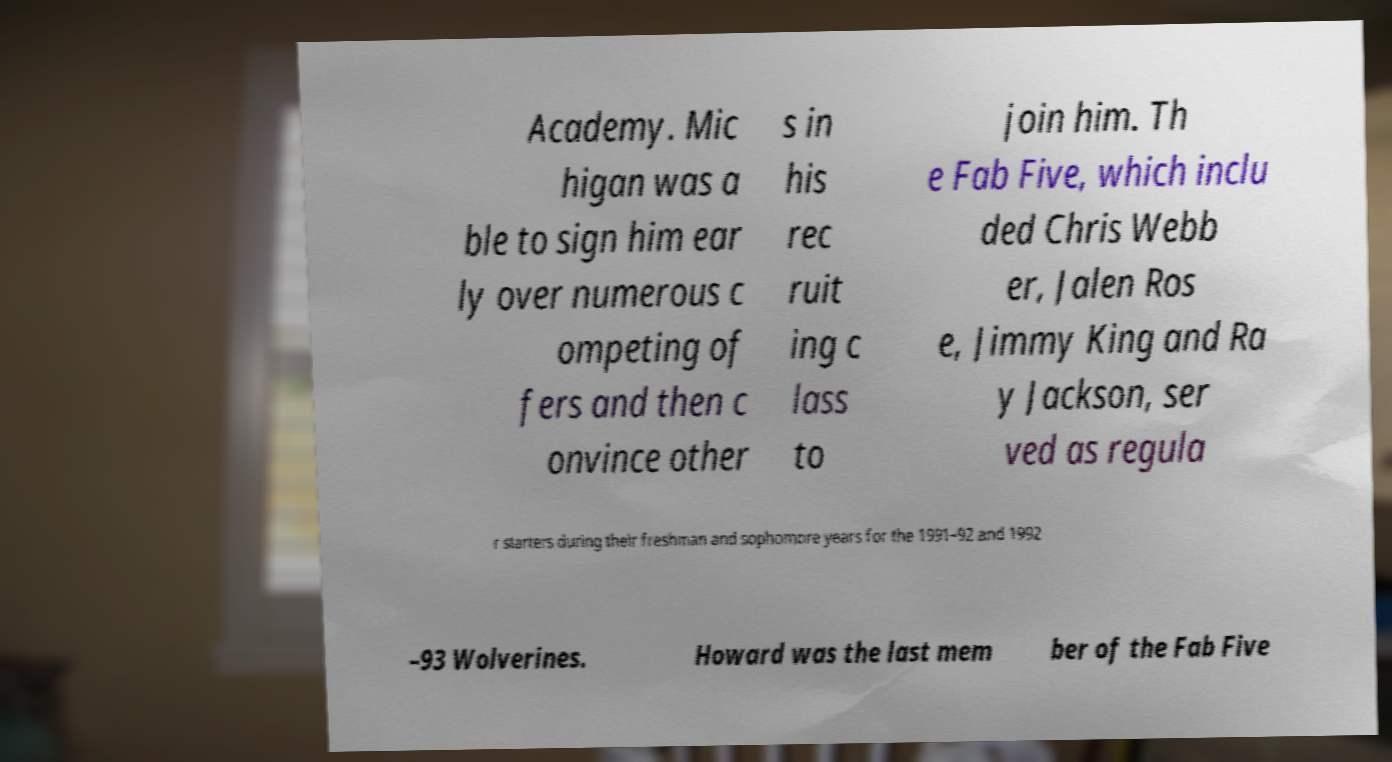What messages or text are displayed in this image? I need them in a readable, typed format. Academy. Mic higan was a ble to sign him ear ly over numerous c ompeting of fers and then c onvince other s in his rec ruit ing c lass to join him. Th e Fab Five, which inclu ded Chris Webb er, Jalen Ros e, Jimmy King and Ra y Jackson, ser ved as regula r starters during their freshman and sophomore years for the 1991–92 and 1992 –93 Wolverines. Howard was the last mem ber of the Fab Five 